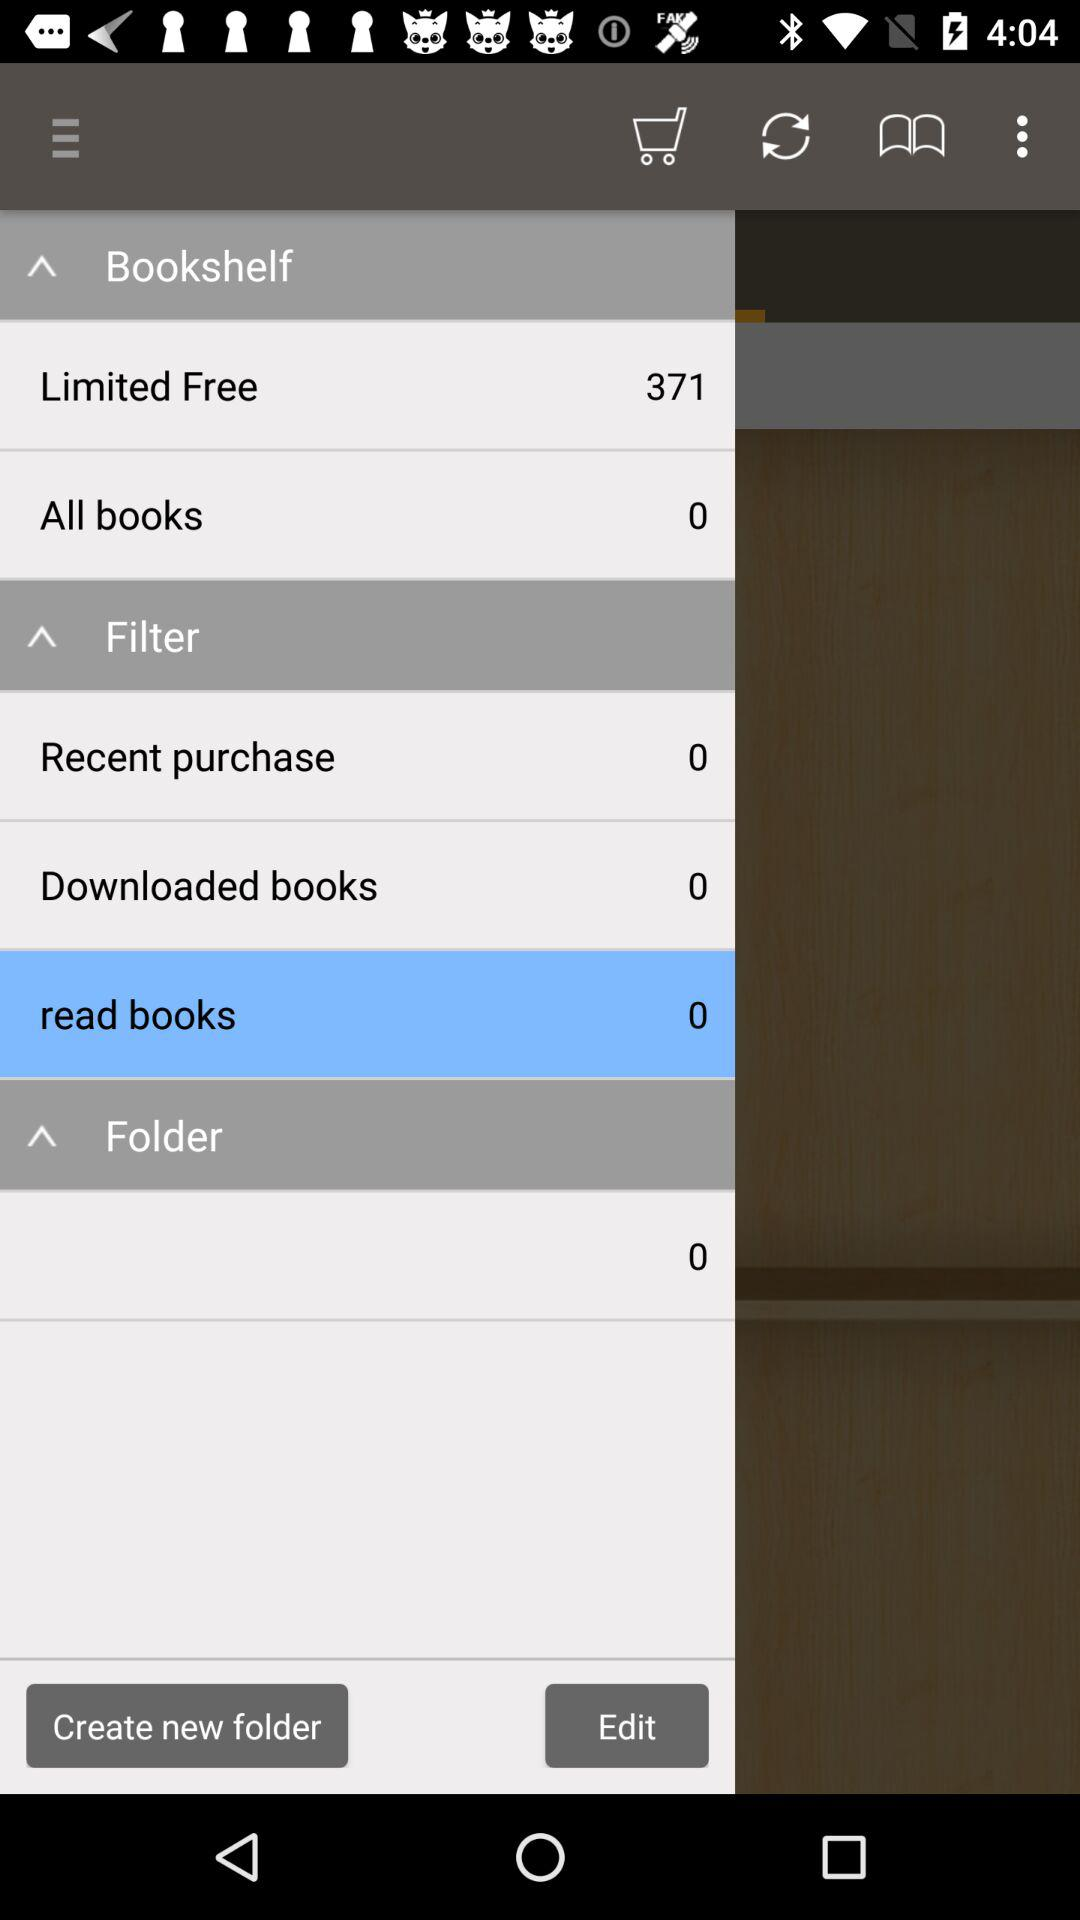How many books are present in "Limited Free"? The number of books that are present in "Limited Free" is 371. 